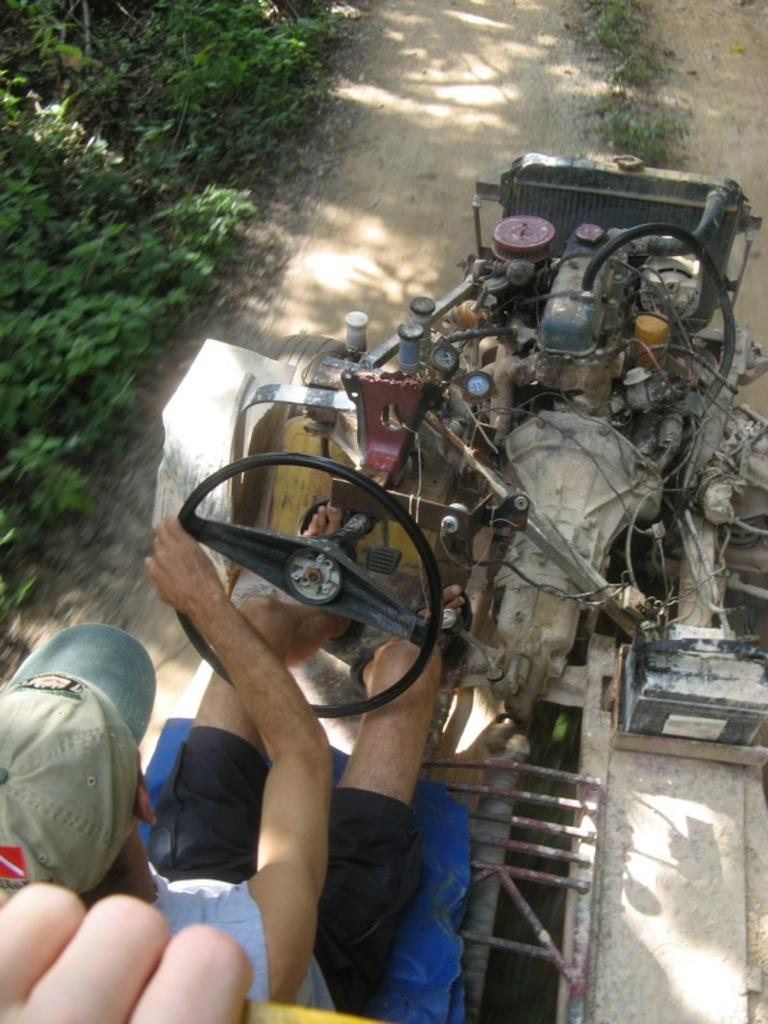What is the person in the image doing? The person in the image is driving a vehicle. What can be seen on the left side of the image? There are plants on the left side of the image. What type of vegetation is present in the center of the image? There is grass on the ground in the center of the image. Can you see a zebra playing a drum in the image? No, there is no zebra or drum present in the image. 